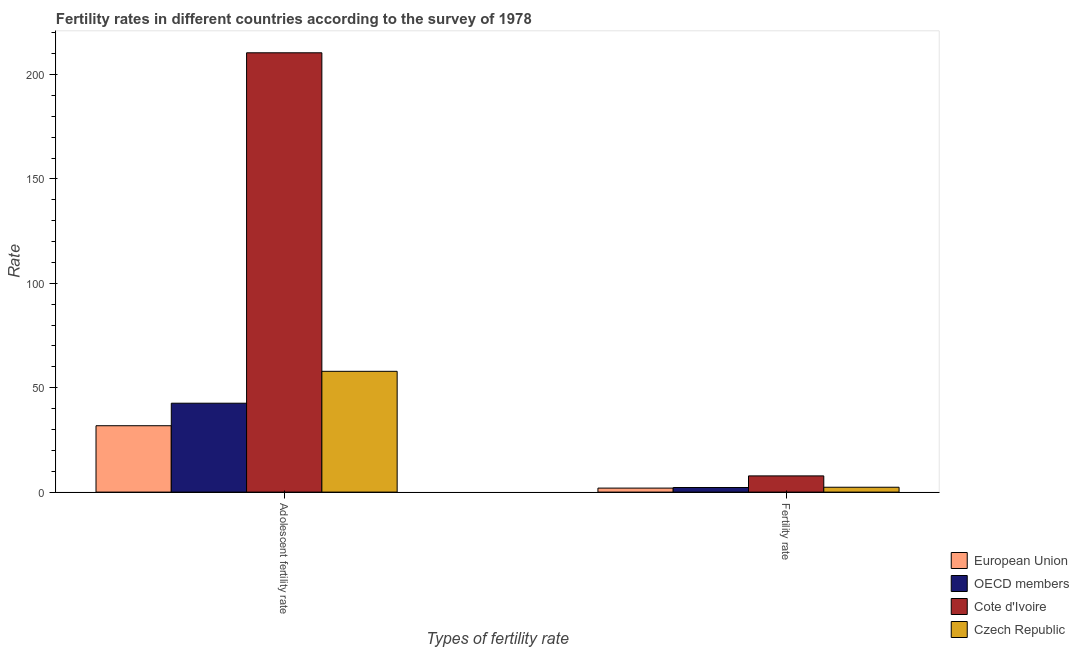How many different coloured bars are there?
Provide a short and direct response. 4. How many groups of bars are there?
Offer a very short reply. 2. Are the number of bars per tick equal to the number of legend labels?
Ensure brevity in your answer.  Yes. How many bars are there on the 1st tick from the left?
Ensure brevity in your answer.  4. How many bars are there on the 2nd tick from the right?
Your answer should be very brief. 4. What is the label of the 2nd group of bars from the left?
Provide a short and direct response. Fertility rate. What is the adolescent fertility rate in OECD members?
Provide a short and direct response. 42.58. Across all countries, what is the maximum adolescent fertility rate?
Your answer should be very brief. 210.42. Across all countries, what is the minimum fertility rate?
Your response must be concise. 1.92. In which country was the adolescent fertility rate maximum?
Your response must be concise. Cote d'Ivoire. In which country was the fertility rate minimum?
Provide a succinct answer. European Union. What is the total adolescent fertility rate in the graph?
Offer a terse response. 342.64. What is the difference between the fertility rate in European Union and that in Czech Republic?
Give a very brief answer. -0.41. What is the difference between the fertility rate in European Union and the adolescent fertility rate in Czech Republic?
Ensure brevity in your answer.  -55.93. What is the average adolescent fertility rate per country?
Ensure brevity in your answer.  85.66. What is the difference between the fertility rate and adolescent fertility rate in OECD members?
Offer a terse response. -40.37. In how many countries, is the adolescent fertility rate greater than 140 ?
Your answer should be compact. 1. What is the ratio of the adolescent fertility rate in Czech Republic to that in OECD members?
Provide a short and direct response. 1.36. In how many countries, is the fertility rate greater than the average fertility rate taken over all countries?
Offer a very short reply. 1. What does the 3rd bar from the right in Adolescent fertility rate represents?
Offer a terse response. OECD members. Are all the bars in the graph horizontal?
Your answer should be compact. No. How many countries are there in the graph?
Ensure brevity in your answer.  4. Does the graph contain any zero values?
Ensure brevity in your answer.  No. How many legend labels are there?
Your answer should be very brief. 4. How are the legend labels stacked?
Provide a succinct answer. Vertical. What is the title of the graph?
Make the answer very short. Fertility rates in different countries according to the survey of 1978. Does "Vanuatu" appear as one of the legend labels in the graph?
Your response must be concise. No. What is the label or title of the X-axis?
Your answer should be very brief. Types of fertility rate. What is the label or title of the Y-axis?
Provide a succinct answer. Rate. What is the Rate of European Union in Adolescent fertility rate?
Your answer should be very brief. 31.8. What is the Rate in OECD members in Adolescent fertility rate?
Your answer should be very brief. 42.58. What is the Rate of Cote d'Ivoire in Adolescent fertility rate?
Offer a terse response. 210.42. What is the Rate of Czech Republic in Adolescent fertility rate?
Your answer should be very brief. 57.85. What is the Rate in European Union in Fertility rate?
Give a very brief answer. 1.92. What is the Rate of OECD members in Fertility rate?
Keep it short and to the point. 2.2. What is the Rate of Cote d'Ivoire in Fertility rate?
Your answer should be compact. 7.76. What is the Rate of Czech Republic in Fertility rate?
Your answer should be very brief. 2.33. Across all Types of fertility rate, what is the maximum Rate of European Union?
Your response must be concise. 31.8. Across all Types of fertility rate, what is the maximum Rate in OECD members?
Offer a terse response. 42.58. Across all Types of fertility rate, what is the maximum Rate in Cote d'Ivoire?
Make the answer very short. 210.42. Across all Types of fertility rate, what is the maximum Rate in Czech Republic?
Your response must be concise. 57.85. Across all Types of fertility rate, what is the minimum Rate in European Union?
Make the answer very short. 1.92. Across all Types of fertility rate, what is the minimum Rate in OECD members?
Provide a succinct answer. 2.2. Across all Types of fertility rate, what is the minimum Rate of Cote d'Ivoire?
Provide a succinct answer. 7.76. Across all Types of fertility rate, what is the minimum Rate in Czech Republic?
Provide a succinct answer. 2.33. What is the total Rate in European Union in the graph?
Provide a short and direct response. 33.72. What is the total Rate of OECD members in the graph?
Your response must be concise. 44.78. What is the total Rate of Cote d'Ivoire in the graph?
Offer a very short reply. 218.18. What is the total Rate in Czech Republic in the graph?
Offer a very short reply. 60.18. What is the difference between the Rate in European Union in Adolescent fertility rate and that in Fertility rate?
Offer a terse response. 29.88. What is the difference between the Rate in OECD members in Adolescent fertility rate and that in Fertility rate?
Ensure brevity in your answer.  40.37. What is the difference between the Rate of Cote d'Ivoire in Adolescent fertility rate and that in Fertility rate?
Ensure brevity in your answer.  202.65. What is the difference between the Rate in Czech Republic in Adolescent fertility rate and that in Fertility rate?
Make the answer very short. 55.52. What is the difference between the Rate in European Union in Adolescent fertility rate and the Rate in OECD members in Fertility rate?
Your response must be concise. 29.59. What is the difference between the Rate of European Union in Adolescent fertility rate and the Rate of Cote d'Ivoire in Fertility rate?
Keep it short and to the point. 24.03. What is the difference between the Rate in European Union in Adolescent fertility rate and the Rate in Czech Republic in Fertility rate?
Give a very brief answer. 29.47. What is the difference between the Rate in OECD members in Adolescent fertility rate and the Rate in Cote d'Ivoire in Fertility rate?
Make the answer very short. 34.81. What is the difference between the Rate in OECD members in Adolescent fertility rate and the Rate in Czech Republic in Fertility rate?
Give a very brief answer. 40.25. What is the difference between the Rate in Cote d'Ivoire in Adolescent fertility rate and the Rate in Czech Republic in Fertility rate?
Provide a short and direct response. 208.09. What is the average Rate of European Union per Types of fertility rate?
Offer a terse response. 16.86. What is the average Rate of OECD members per Types of fertility rate?
Offer a terse response. 22.39. What is the average Rate of Cote d'Ivoire per Types of fertility rate?
Offer a terse response. 109.09. What is the average Rate of Czech Republic per Types of fertility rate?
Offer a very short reply. 30.09. What is the difference between the Rate in European Union and Rate in OECD members in Adolescent fertility rate?
Offer a terse response. -10.78. What is the difference between the Rate in European Union and Rate in Cote d'Ivoire in Adolescent fertility rate?
Offer a very short reply. -178.62. What is the difference between the Rate in European Union and Rate in Czech Republic in Adolescent fertility rate?
Your answer should be very brief. -26.05. What is the difference between the Rate in OECD members and Rate in Cote d'Ivoire in Adolescent fertility rate?
Ensure brevity in your answer.  -167.84. What is the difference between the Rate of OECD members and Rate of Czech Republic in Adolescent fertility rate?
Your answer should be compact. -15.27. What is the difference between the Rate in Cote d'Ivoire and Rate in Czech Republic in Adolescent fertility rate?
Give a very brief answer. 152.57. What is the difference between the Rate in European Union and Rate in OECD members in Fertility rate?
Keep it short and to the point. -0.28. What is the difference between the Rate in European Union and Rate in Cote d'Ivoire in Fertility rate?
Give a very brief answer. -5.85. What is the difference between the Rate of European Union and Rate of Czech Republic in Fertility rate?
Offer a terse response. -0.41. What is the difference between the Rate of OECD members and Rate of Cote d'Ivoire in Fertility rate?
Ensure brevity in your answer.  -5.56. What is the difference between the Rate in OECD members and Rate in Czech Republic in Fertility rate?
Give a very brief answer. -0.13. What is the difference between the Rate in Cote d'Ivoire and Rate in Czech Republic in Fertility rate?
Provide a succinct answer. 5.43. What is the ratio of the Rate in European Union in Adolescent fertility rate to that in Fertility rate?
Offer a terse response. 16.56. What is the ratio of the Rate in OECD members in Adolescent fertility rate to that in Fertility rate?
Ensure brevity in your answer.  19.32. What is the ratio of the Rate of Cote d'Ivoire in Adolescent fertility rate to that in Fertility rate?
Offer a terse response. 27.1. What is the ratio of the Rate of Czech Republic in Adolescent fertility rate to that in Fertility rate?
Your response must be concise. 24.83. What is the difference between the highest and the second highest Rate of European Union?
Ensure brevity in your answer.  29.88. What is the difference between the highest and the second highest Rate in OECD members?
Give a very brief answer. 40.37. What is the difference between the highest and the second highest Rate of Cote d'Ivoire?
Provide a succinct answer. 202.65. What is the difference between the highest and the second highest Rate in Czech Republic?
Your answer should be very brief. 55.52. What is the difference between the highest and the lowest Rate in European Union?
Offer a terse response. 29.88. What is the difference between the highest and the lowest Rate of OECD members?
Your response must be concise. 40.37. What is the difference between the highest and the lowest Rate in Cote d'Ivoire?
Offer a very short reply. 202.65. What is the difference between the highest and the lowest Rate of Czech Republic?
Keep it short and to the point. 55.52. 